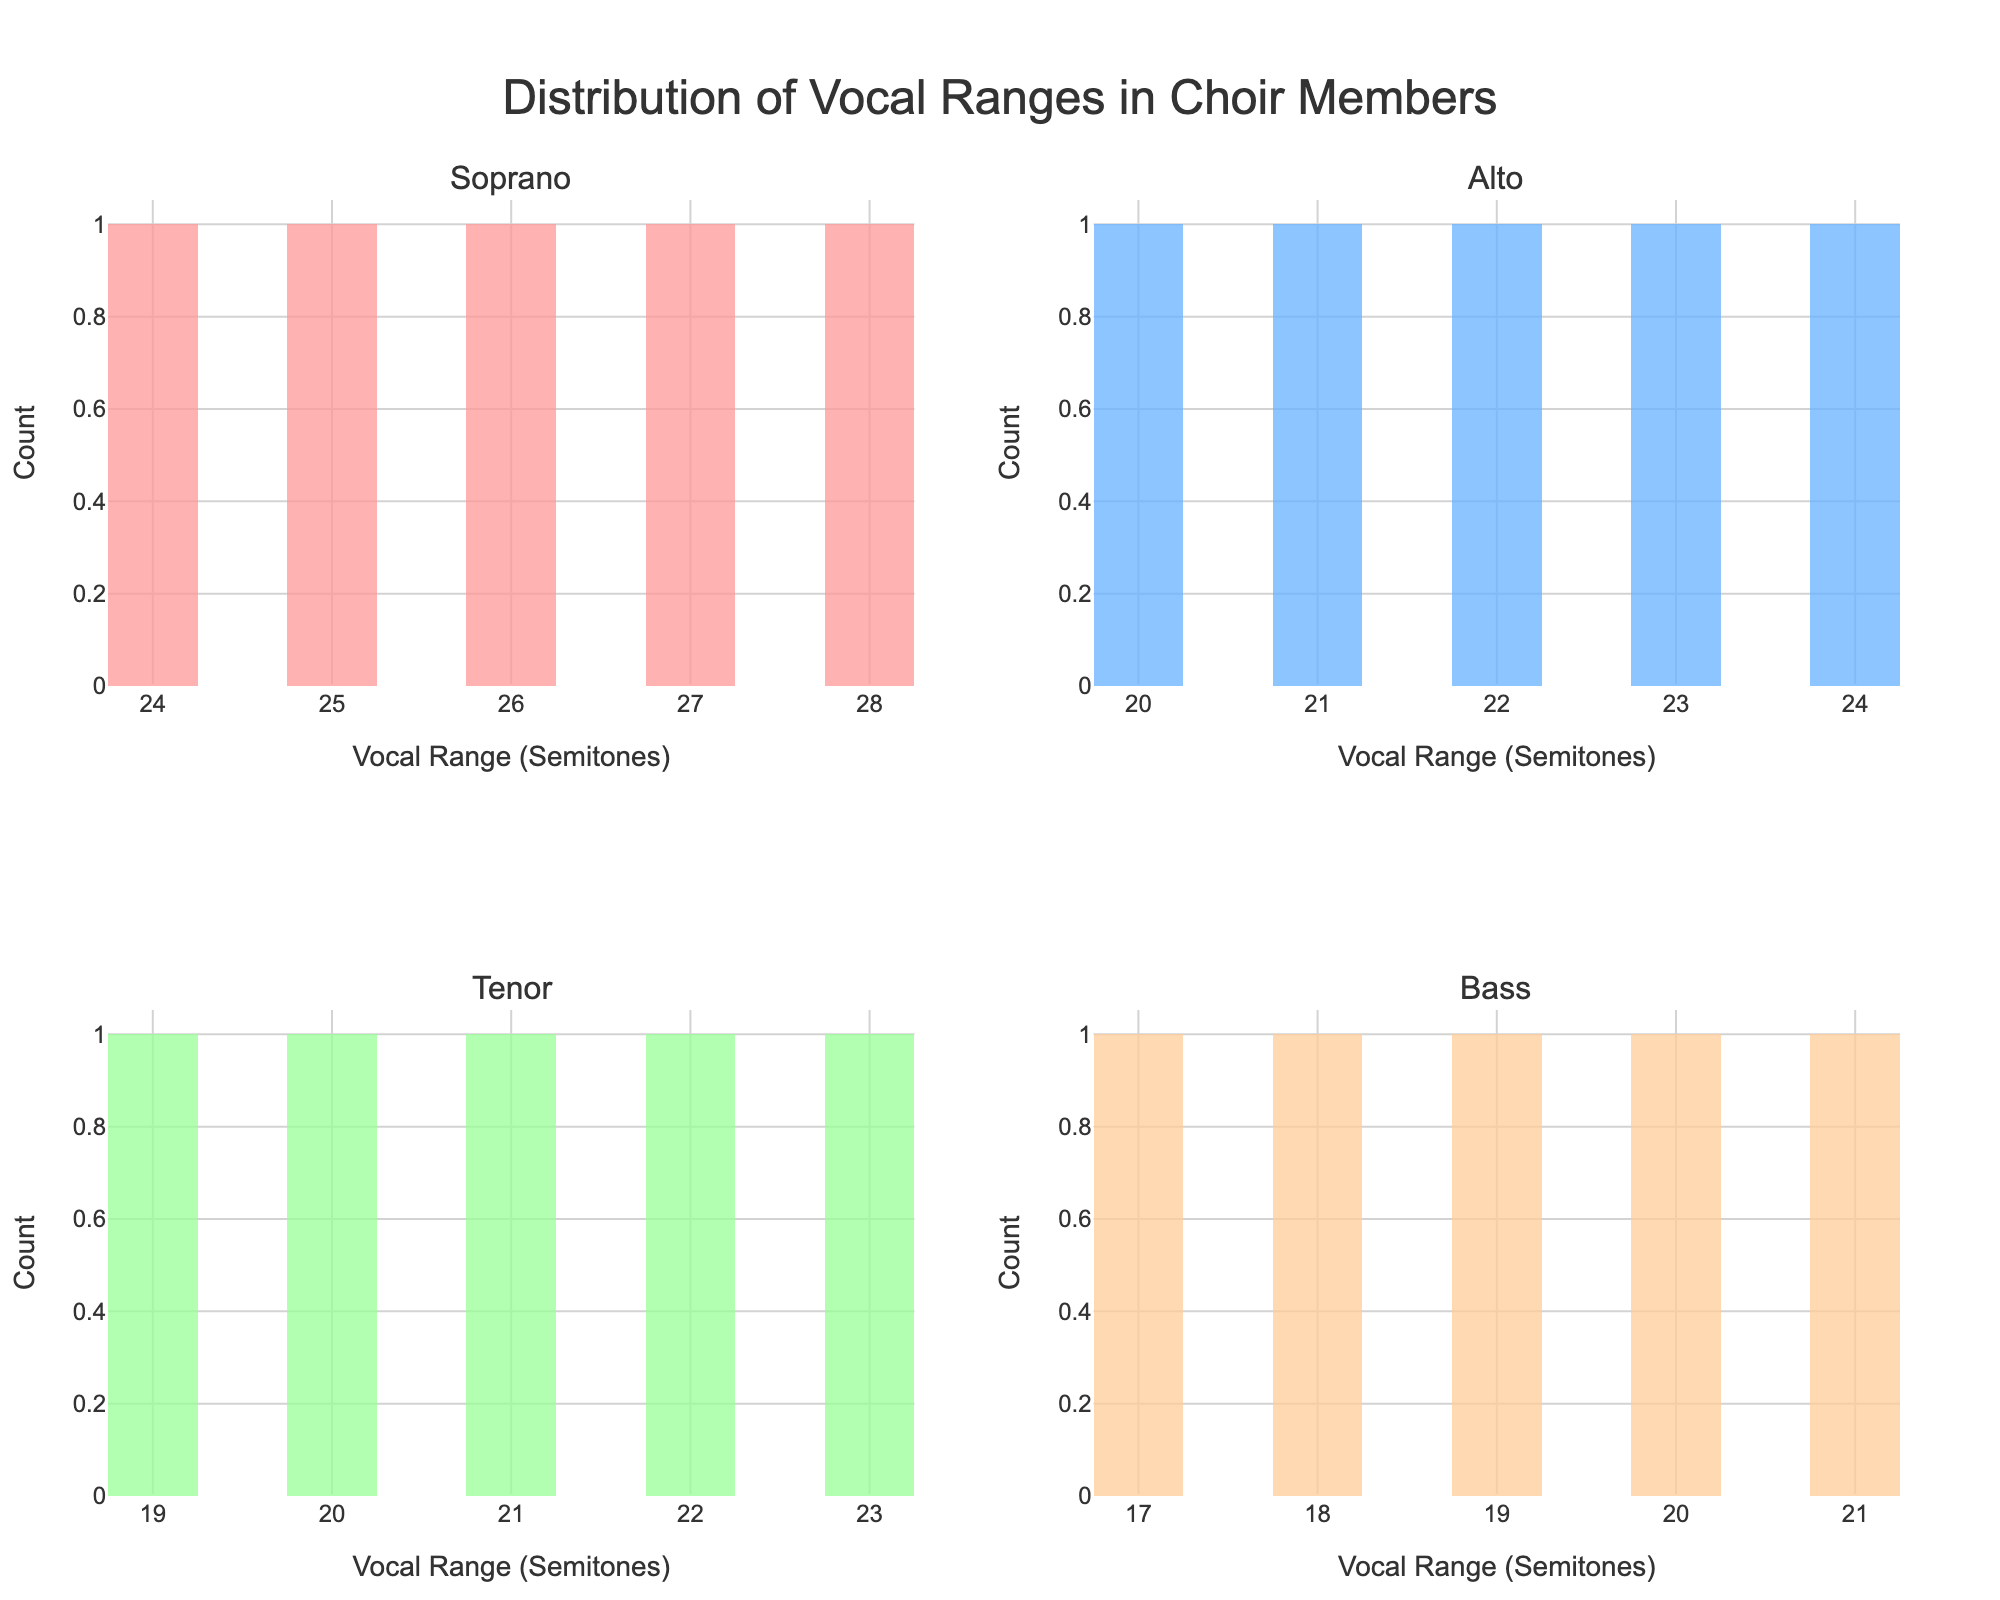Which voice type has the widest range of semitone values? The widest range can be determined by comparing the maximum and minimum semitone values within each voice type. Soprano has a range from 24 to 28 which is 4 semitones, Alto ranges from 20 to 24 which is also 4 semitones, Tenor ranges from 19 to 23 which is 4 semitones, and Bass ranges from 17 to 21 which is also 4 semitones. Therefore, all voice types have the same range of semitone values.
Answer: All voice types have the same range Which subplot has the highest peak count? The highest peak can be identified by looking at the tallest bar in each subplot. In this case, the Soprano subplot has the highest bar, indicating the highest peak count.
Answer: Soprano What is the median vocal range for the Tenor voice type? The median can be found by ordering the Tenor data points (19, 20, 21, 22, 23) and locating the middle value. The median for Tenor is 21.
Answer: 21 How many Bass members have a vocal range of 19 semitones? The height of the bar at 19 semitones in the Bass subplot indicates the count of Bass members with this vocal range. There are 2 members with a vocal range of 19 semitones.
Answer: 2 Which voice type has the modal vocal range (the range that appears most frequently)? The mode can be identified by finding the tallest bar in each subplot. For Soprano, it is 25 and 26 (both have equal height), for Alto, it is 22, for Tenor, it is 21, and for Bass, it is 19. Comparing these, the tallest overall bars are 25 and 26 in the Soprano subplot. Therefore, Soprano has the modal vocal range of 25 and 26 semitones.
Answer: Soprano What is the total number of members in the Alto voice type? The total count of members in the Alto voice type can be determined by summing the heights of all bars in the Alto subplot. Adding up the counts for Alto voice type (22=1, 20=1, 23=1, 21=1, 24=1) gives a total of 5 members.
Answer: 5 Which vocal range has the least frequency in the Bass voice type? The frequency of the least common vocal range is represented by the shortest bars. In the Bass subplot, 17 and 18 have the least frequency with a count of 1 each.
Answer: 17 and 18 semitones What are the vocal ranges covered in the Alto voice type? The ranges are given by the x-axis values with bars in the Alto subplot. The ranges for Alto are 20, 21, 22, 23, and 24 semitones.
Answer: 20-24 semitones Which voice type has the most diverse vocal range spread by visual inspection? The spread of vocal ranges can be seen from the length of the x-axis with bars. All the voice types have bars spread across exactly 4 semitones. Therefore, all have the same vocal range spread.
Answer: All voice types 